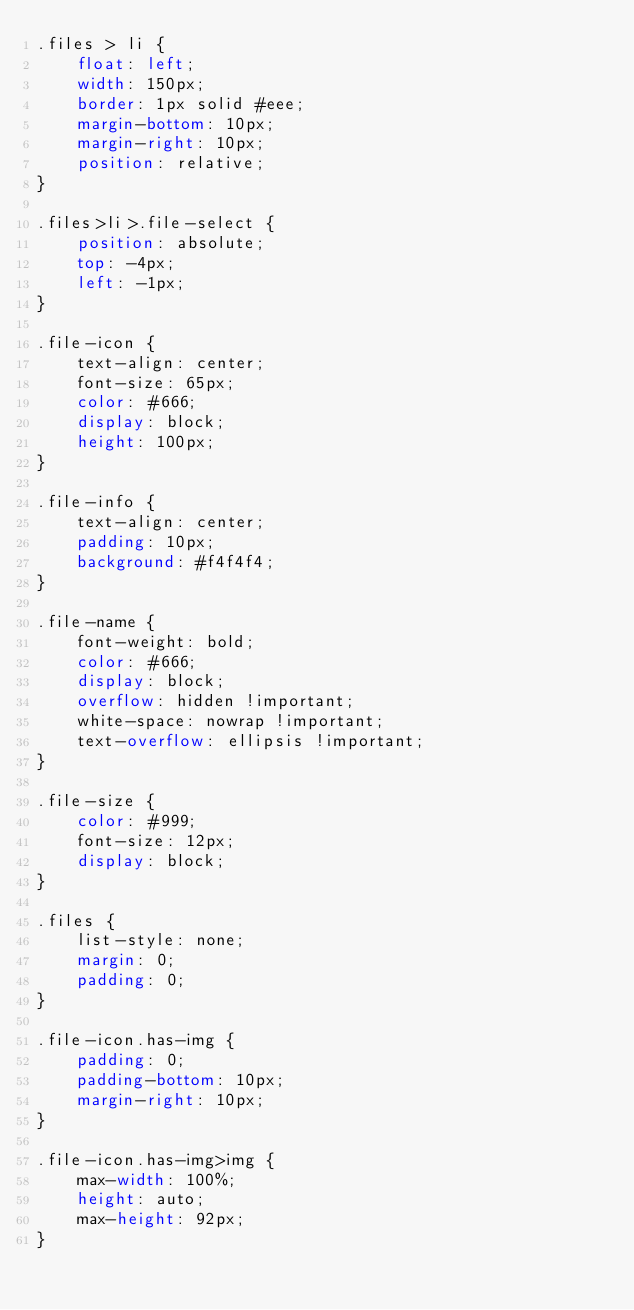Convert code to text. <code><loc_0><loc_0><loc_500><loc_500><_CSS_>.files > li {
    float: left;
    width: 150px;
    border: 1px solid #eee;
    margin-bottom: 10px;
    margin-right: 10px;
    position: relative;
}

.files>li>.file-select {
    position: absolute;
    top: -4px;
    left: -1px;
}

.file-icon {
    text-align: center;
    font-size: 65px;
    color: #666;
    display: block;
    height: 100px;
}

.file-info {
    text-align: center;
    padding: 10px;
    background: #f4f4f4;
}

.file-name {
    font-weight: bold;
    color: #666;
    display: block;
    overflow: hidden !important;
    white-space: nowrap !important;
    text-overflow: ellipsis !important;
}

.file-size {
    color: #999;
    font-size: 12px;
    display: block;
}

.files {
    list-style: none;
    margin: 0;
    padding: 0;
}

.file-icon.has-img {
    padding: 0;
    padding-bottom: 10px;
    margin-right: 10px;
}

.file-icon.has-img>img {
    max-width: 100%;
    height: auto;
    max-height: 92px;
}
</code> 